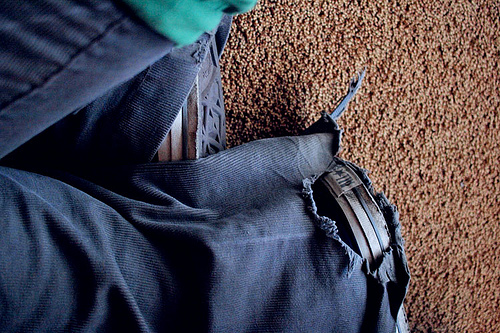<image>
Is the shoe next to the ground? No. The shoe is not positioned next to the ground. They are located in different areas of the scene. 